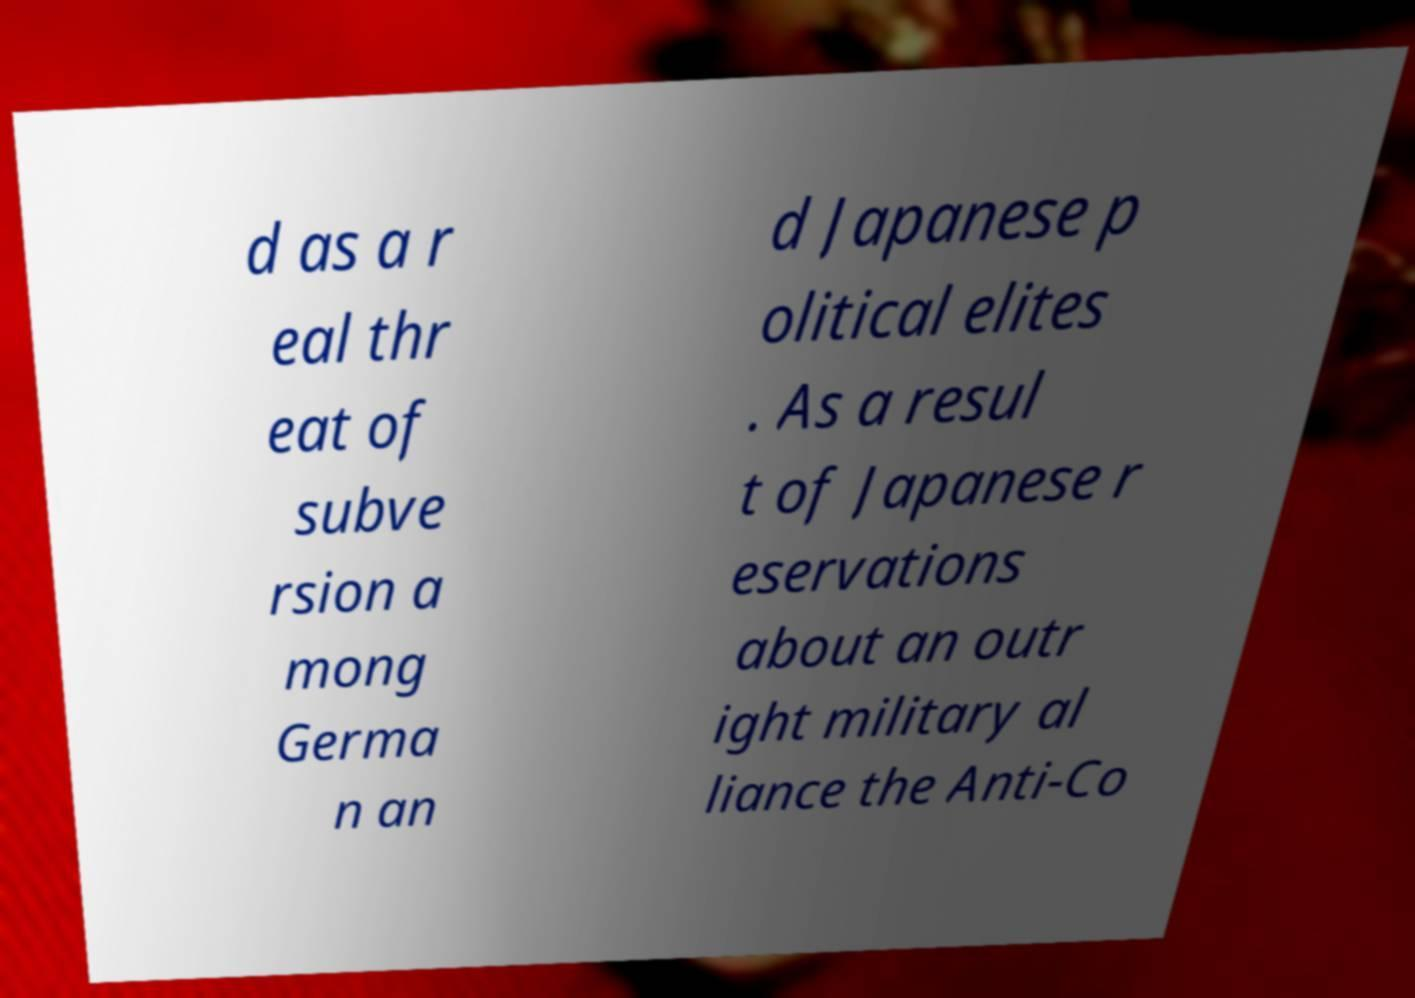Could you extract and type out the text from this image? d as a r eal thr eat of subve rsion a mong Germa n an d Japanese p olitical elites . As a resul t of Japanese r eservations about an outr ight military al liance the Anti-Co 